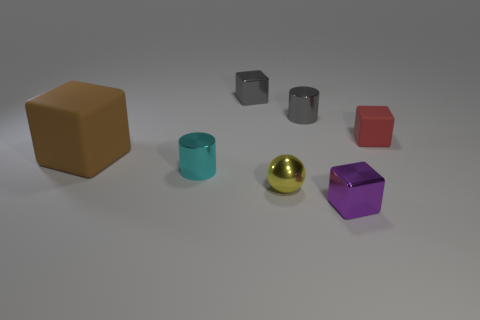There is a object that is behind the cyan metal cylinder and to the right of the gray cylinder; what color is it?
Keep it short and to the point. Red. There is a rubber cube on the right side of the yellow metallic thing; is there a gray cylinder right of it?
Your response must be concise. No. Are there the same number of small yellow metal spheres on the right side of the red matte cube and tiny cyan rubber objects?
Keep it short and to the point. Yes. There is a small metallic cylinder behind the thing on the left side of the small cyan metal object; what number of spheres are on the left side of it?
Keep it short and to the point. 1. Is there a gray metal cylinder of the same size as the purple metallic thing?
Provide a succinct answer. Yes. Is the number of tiny objects that are right of the red block less than the number of tiny purple metal things?
Provide a short and direct response. Yes. What material is the thing to the right of the tiny metal block in front of the cylinder that is behind the small cyan cylinder?
Provide a succinct answer. Rubber. Are there more tiny purple things that are in front of the small red cube than shiny blocks on the right side of the yellow object?
Your answer should be compact. No. What number of metallic objects are big cyan cubes or small gray cubes?
Provide a short and direct response. 1. What material is the small yellow thing on the left side of the tiny purple thing?
Your answer should be compact. Metal. 